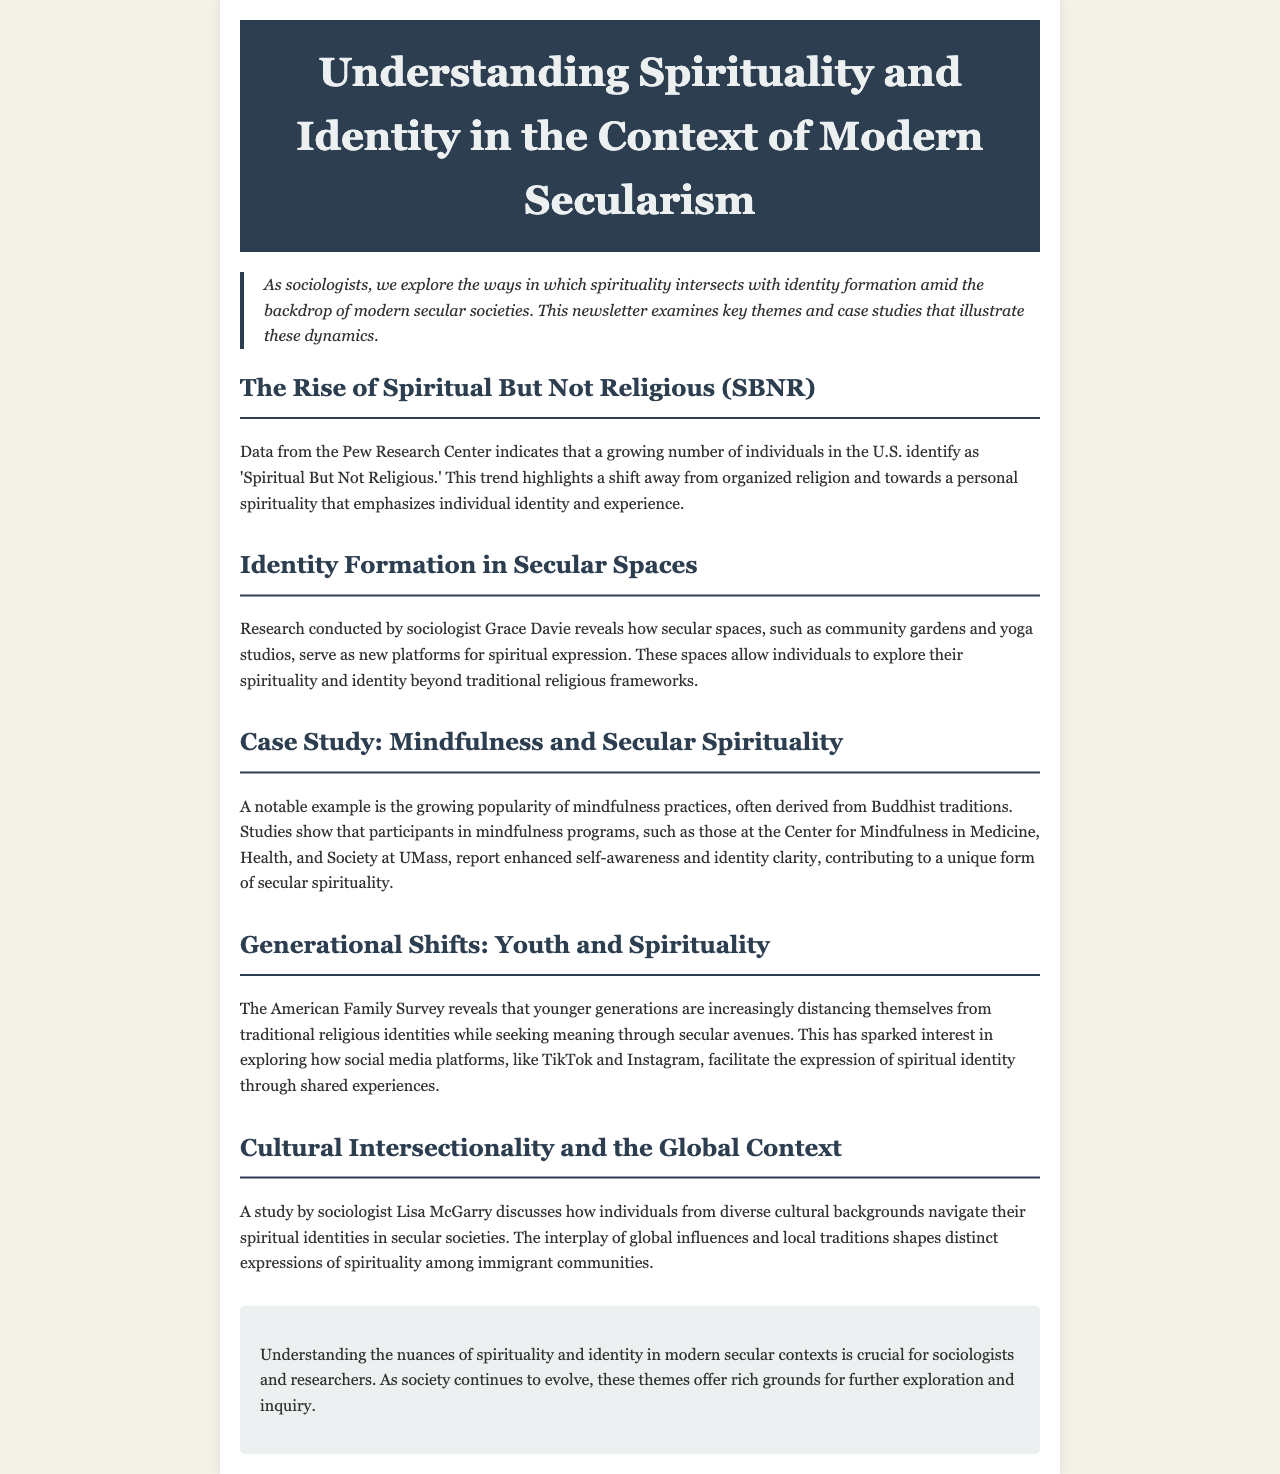What is the title of the newsletter? The title is explicitly stated at the top of the document.
Answer: Understanding Spirituality and Identity in the Context of Modern Secularism What does SBNR stand for? This abbreviation is mentioned in the section discussing trends in spirituality in the U.S.
Answer: Spiritual But Not Religious Which sociologist conducted research on identity formation in secular spaces? The name is mentioned in the section focusing on secular spaces and spirituality.
Answer: Grace Davie What popular practice derived from Buddhist traditions is discussed? The document discusses the growing popularity of this practice under the case study section.
Answer: Mindfulness Which social media platforms are mentioned in relation to youth spirituality? These platforms are referenced in the section about generational shifts in spirituality.
Answer: TikTok and Instagram What is a new platform for spiritual expression mentioned in the document? This platform is highlighted in the section on identity formation in secular spaces.
Answer: Community gardens What does the American Family Survey reveal about younger generations? This finding is noted in the section regarding youth and spirituality.
Answer: Distancing from traditional religious identities Which sociologist is mentioned in the context of cultural intersectionality? The name is given in the section pertaining to diverse cultural backgrounds in secular societies.
Answer: Lisa McGarry 